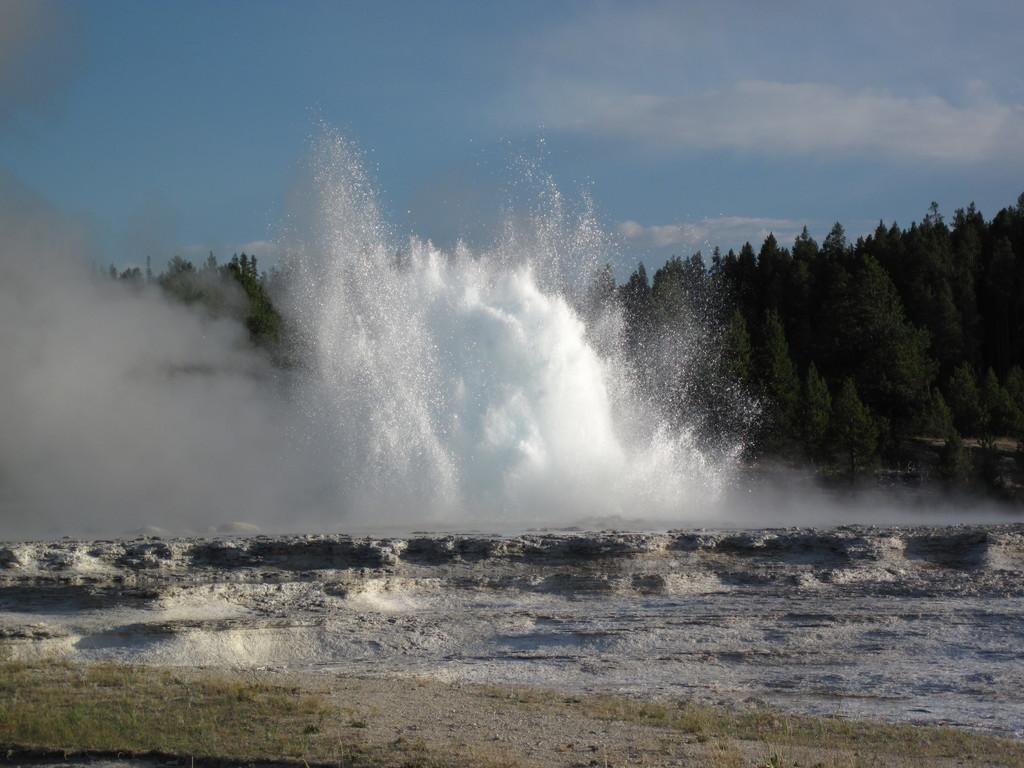Can you describe this image briefly? This image is taken outdoors. At the bottom of the image there is a ground. In the middle of the image there is a water splash. In the background there are many trees. At the top of the image there is a sky with clouds. 